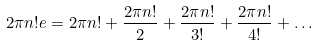<formula> <loc_0><loc_0><loc_500><loc_500>2 \pi n ! e = 2 \pi n ! + \frac { 2 \pi n ! } { 2 } + \frac { 2 \pi n ! } { 3 ! } + \frac { 2 \pi n ! } { 4 ! } + \dots</formula> 